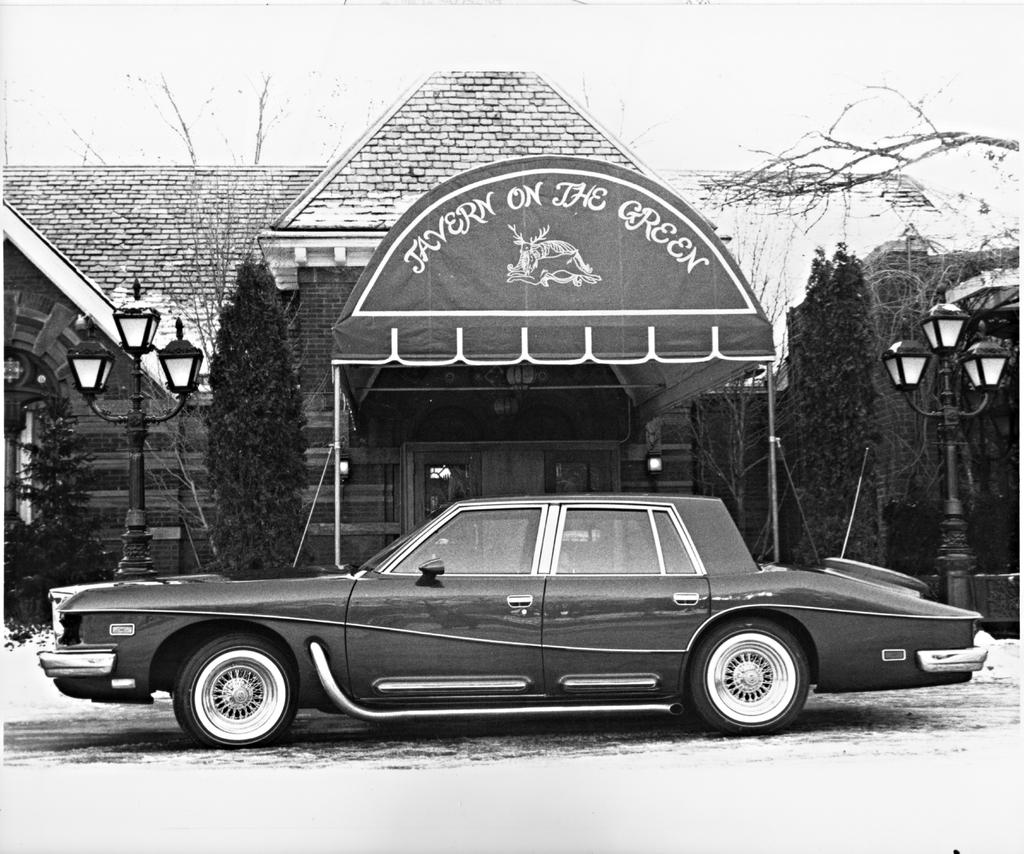What is the main subject of the image? There is a car in the image. What else can be seen in the image besides the car? There is a banner with text, houses in the background, a glass door, trees, and the sky visible at the top of the image. How many breaths can be seen coming from the car in the image? There are no breaths visible in the image, as cars do not breathe. 